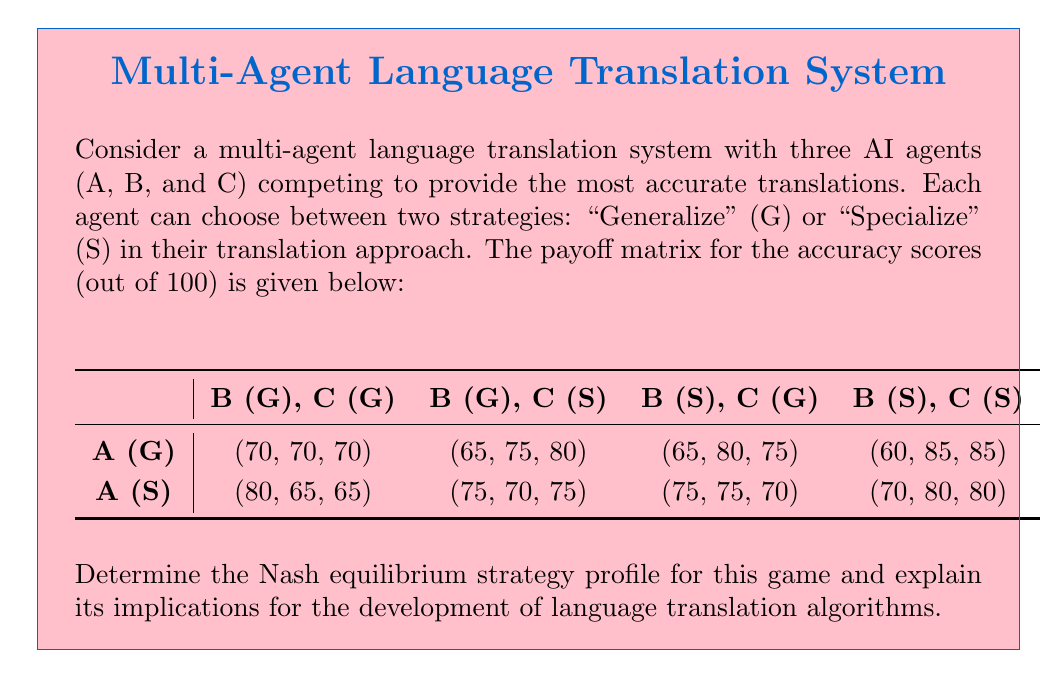Could you help me with this problem? To solve this problem, we need to analyze the payoff matrix and determine the best response strategies for each agent. A Nash equilibrium occurs when no agent can unilaterally improve their payoff by changing their strategy.

Step 1: Identify dominant strategies (if any)
First, we check if any agent has a dominant strategy. By comparing the payoffs for each strategy across all possible combinations of other agents' strategies, we find that there are no dominant strategies for any agent.

Step 2: Find best responses
We now need to find the best response for each agent given the other agents' strategies:

For Agent A:
- If B and C both choose G: A's best response is S (80 > 70)
- If B chooses G and C chooses S: A's best response is S (75 > 65)
- If B chooses S and C chooses G: A's best response is S (75 > 65)
- If B and C both choose S: A's best response is S (70 > 60)

For Agent B:
- If A chooses G and C chooses G: B's best response is S (80 > 70)
- If A chooses G and C chooses S: B's best response is S (85 > 75)
- If A chooses S and C chooses G: B's best response is S (75 > 65)
- If A chooses S and C chooses S: B's best response is S (80 > 70)

For Agent C:
- If A chooses G and B chooses G: C's best response is S (80 > 70)
- If A chooses G and B chooses S: C's best response is S (85 > 75)
- If A chooses S and B chooses G: C's best response is S (75 > 65)
- If A chooses S and B chooses S: C's best response is S (80 > 70)

Step 3: Identify Nash equilibrium
From the best responses, we can see that the only strategy profile where all agents are playing their best response simultaneously is (S, S, S), where all agents choose to Specialize.

Step 4: Interpret the results
In this Nash equilibrium, all agents choose to Specialize, resulting in a payoff of (70, 80, 80). This means that Agents B and C achieve the highest possible accuracy scores, while Agent A sacrifices some accuracy to specialize.

Implications for language translation algorithms:
1. Specialization is favored: The Nash equilibrium suggests that in a competitive multi-agent system, specializing in specific language pairs or domains may be more beneficial than generalizing across all languages.

2. Trade-offs in accuracy: While specialization leads to higher overall accuracy, some agents (like A in this case) may have to accept lower accuracy scores to maintain the equilibrium.

3. Potential for collaboration: The Nash equilibrium doesn't necessarily lead to the highest possible scores for all agents. This suggests that there might be room for collaborative approaches in developing language translation algorithms.

4. Diversity in translation approaches: The equilibrium encourages diverse specialized translation models, which could lead to more robust and accurate translations when combined.

5. Implications for resource allocation: When developing language translation algorithms, it may be more efficient to focus resources on specialized models rather than trying to create a single, generalized model for all languages and domains.
Answer: The Nash equilibrium strategy profile for this game is (S, S, S), where all three agents choose to Specialize. This results in payoffs of (70, 80, 80) for agents A, B, and C, respectively. 